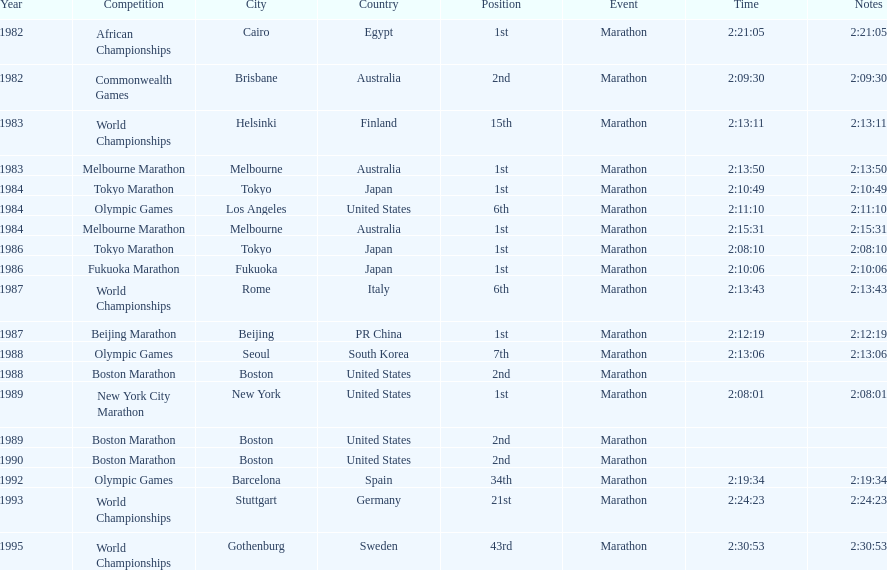I'm looking to parse the entire table for insights. Could you assist me with that? {'header': ['Year', 'Competition', 'City', 'Country', 'Position', 'Event', 'Time', 'Notes'], 'rows': [['1982', 'African Championships', 'Cairo', 'Egypt', '1st', 'Marathon', '2:21:05', '2:21:05'], ['1982', 'Commonwealth Games', 'Brisbane', 'Australia', '2nd', 'Marathon', '2:09:30', '2:09:30'], ['1983', 'World Championships', 'Helsinki', 'Finland', '15th', 'Marathon', '2:13:11', '2:13:11'], ['1983', 'Melbourne Marathon', 'Melbourne', 'Australia', '1st', 'Marathon', '2:13:50', '2:13:50'], ['1984', 'Tokyo Marathon', 'Tokyo', 'Japan', '1st', 'Marathon', '2:10:49', '2:10:49'], ['1984', 'Olympic Games', 'Los Angeles', 'United States', '6th', 'Marathon', '2:11:10', '2:11:10'], ['1984', 'Melbourne Marathon', 'Melbourne', 'Australia', '1st', 'Marathon', '2:15:31', '2:15:31'], ['1986', 'Tokyo Marathon', 'Tokyo', 'Japan', '1st', 'Marathon', '2:08:10', '2:08:10'], ['1986', 'Fukuoka Marathon', 'Fukuoka', 'Japan', '1st', 'Marathon', '2:10:06', '2:10:06'], ['1987', 'World Championships', 'Rome', 'Italy', '6th', 'Marathon', '2:13:43', '2:13:43'], ['1987', 'Beijing Marathon', 'Beijing', 'PR China', '1st', 'Marathon', '2:12:19', '2:12:19'], ['1988', 'Olympic Games', 'Seoul', 'South Korea', '7th', 'Marathon', '2:13:06', '2:13:06'], ['1988', 'Boston Marathon', 'Boston', 'United States', '2nd', 'Marathon', '', ''], ['1989', 'New York City Marathon', 'New York', 'United States', '1st', 'Marathon', '2:08:01', '2:08:01'], ['1989', 'Boston Marathon', 'Boston', 'United States', '2nd', 'Marathon', '', ''], ['1990', 'Boston Marathon', 'Boston', 'United States', '2nd', 'Marathon', '', ''], ['1992', 'Olympic Games', 'Barcelona', 'Spain', '34th', 'Marathon', '2:19:34', '2:19:34'], ['1993', 'World Championships', 'Stuttgart', 'Germany', '21st', 'Marathon', '2:24:23', '2:24:23'], ['1995', 'World Championships', 'Gothenburg', 'Sweden', '43rd', 'Marathon', '2:30:53', '2:30:53']]} Which was the only competition to occur in china? Beijing Marathon. 